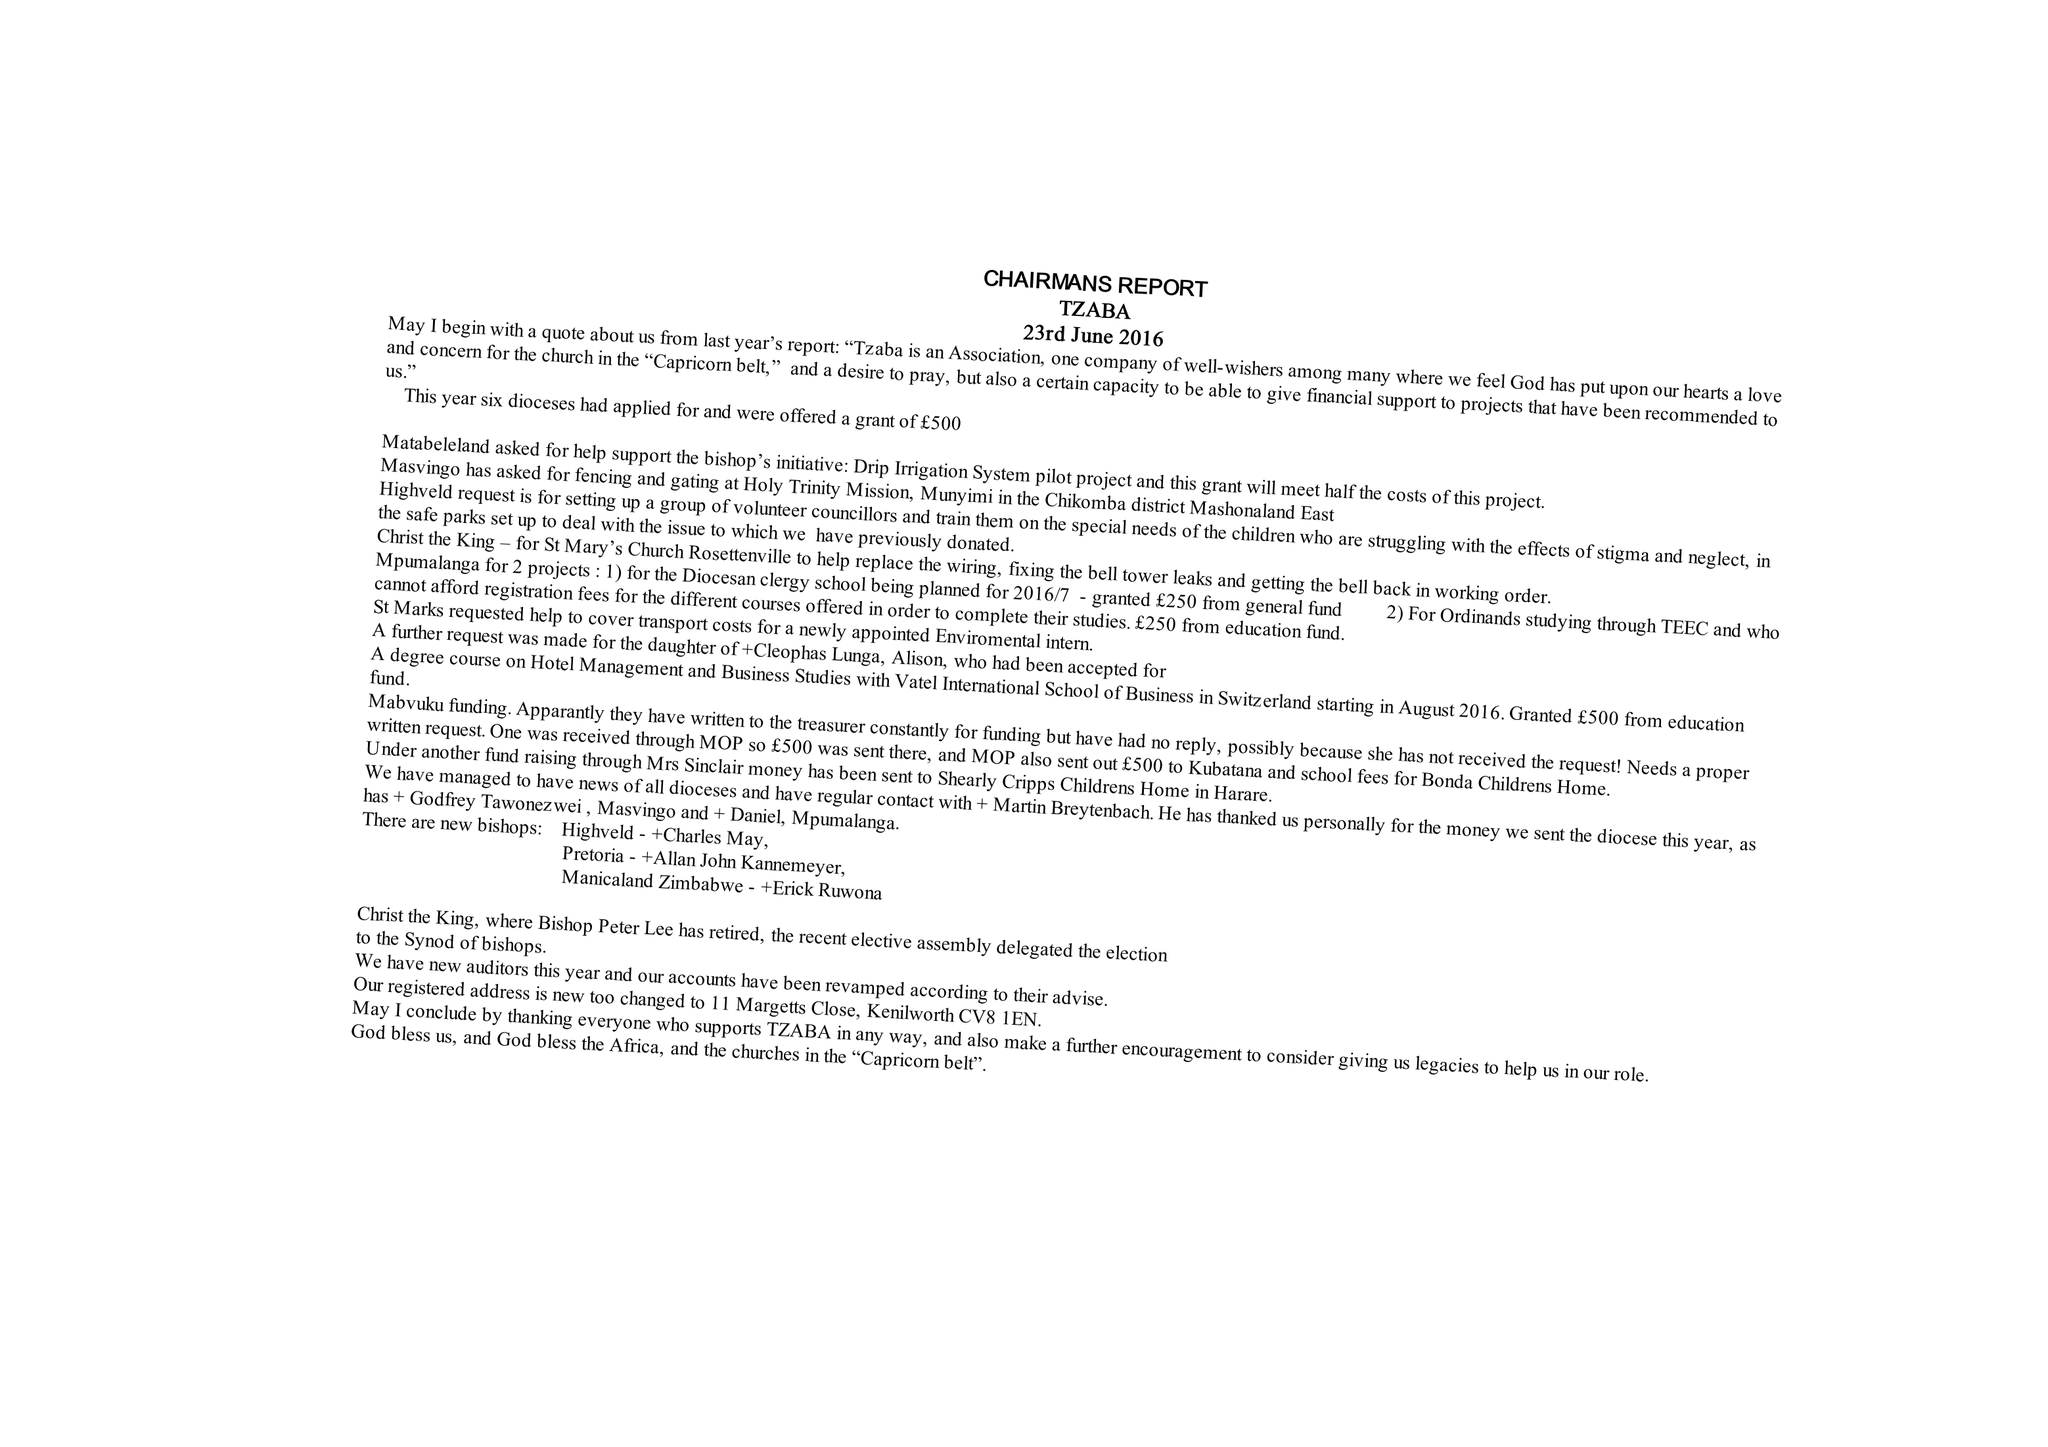What is the value for the report_date?
Answer the question using a single word or phrase. 2016-12-31 